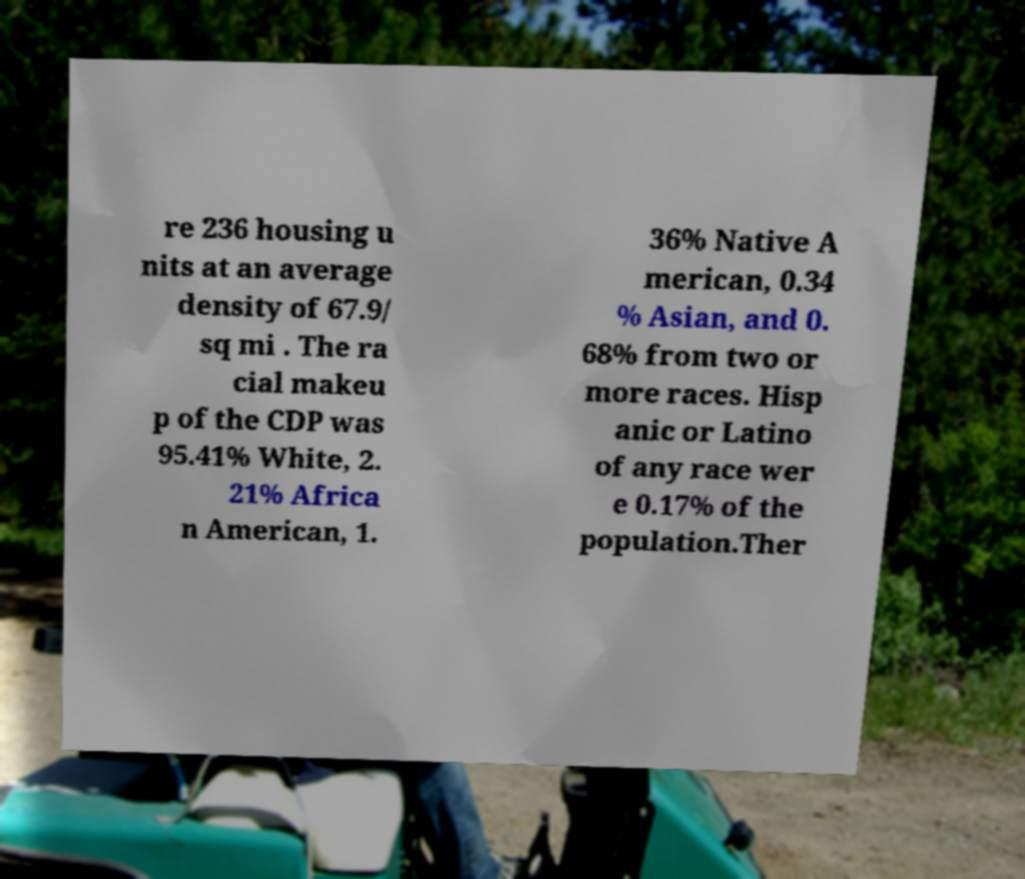Can you accurately transcribe the text from the provided image for me? re 236 housing u nits at an average density of 67.9/ sq mi . The ra cial makeu p of the CDP was 95.41% White, 2. 21% Africa n American, 1. 36% Native A merican, 0.34 % Asian, and 0. 68% from two or more races. Hisp anic or Latino of any race wer e 0.17% of the population.Ther 